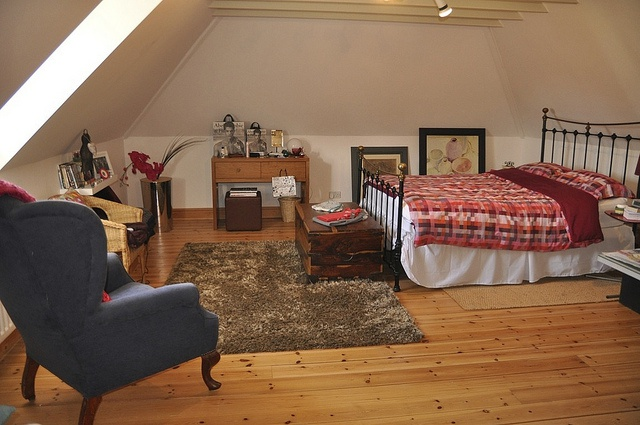Describe the objects in this image and their specific colors. I can see bed in gray, brown, maroon, darkgray, and black tones, chair in gray, black, maroon, and darkgray tones, potted plant in gray, maroon, and black tones, chair in gray, tan, and maroon tones, and book in gray, tan, and black tones in this image. 